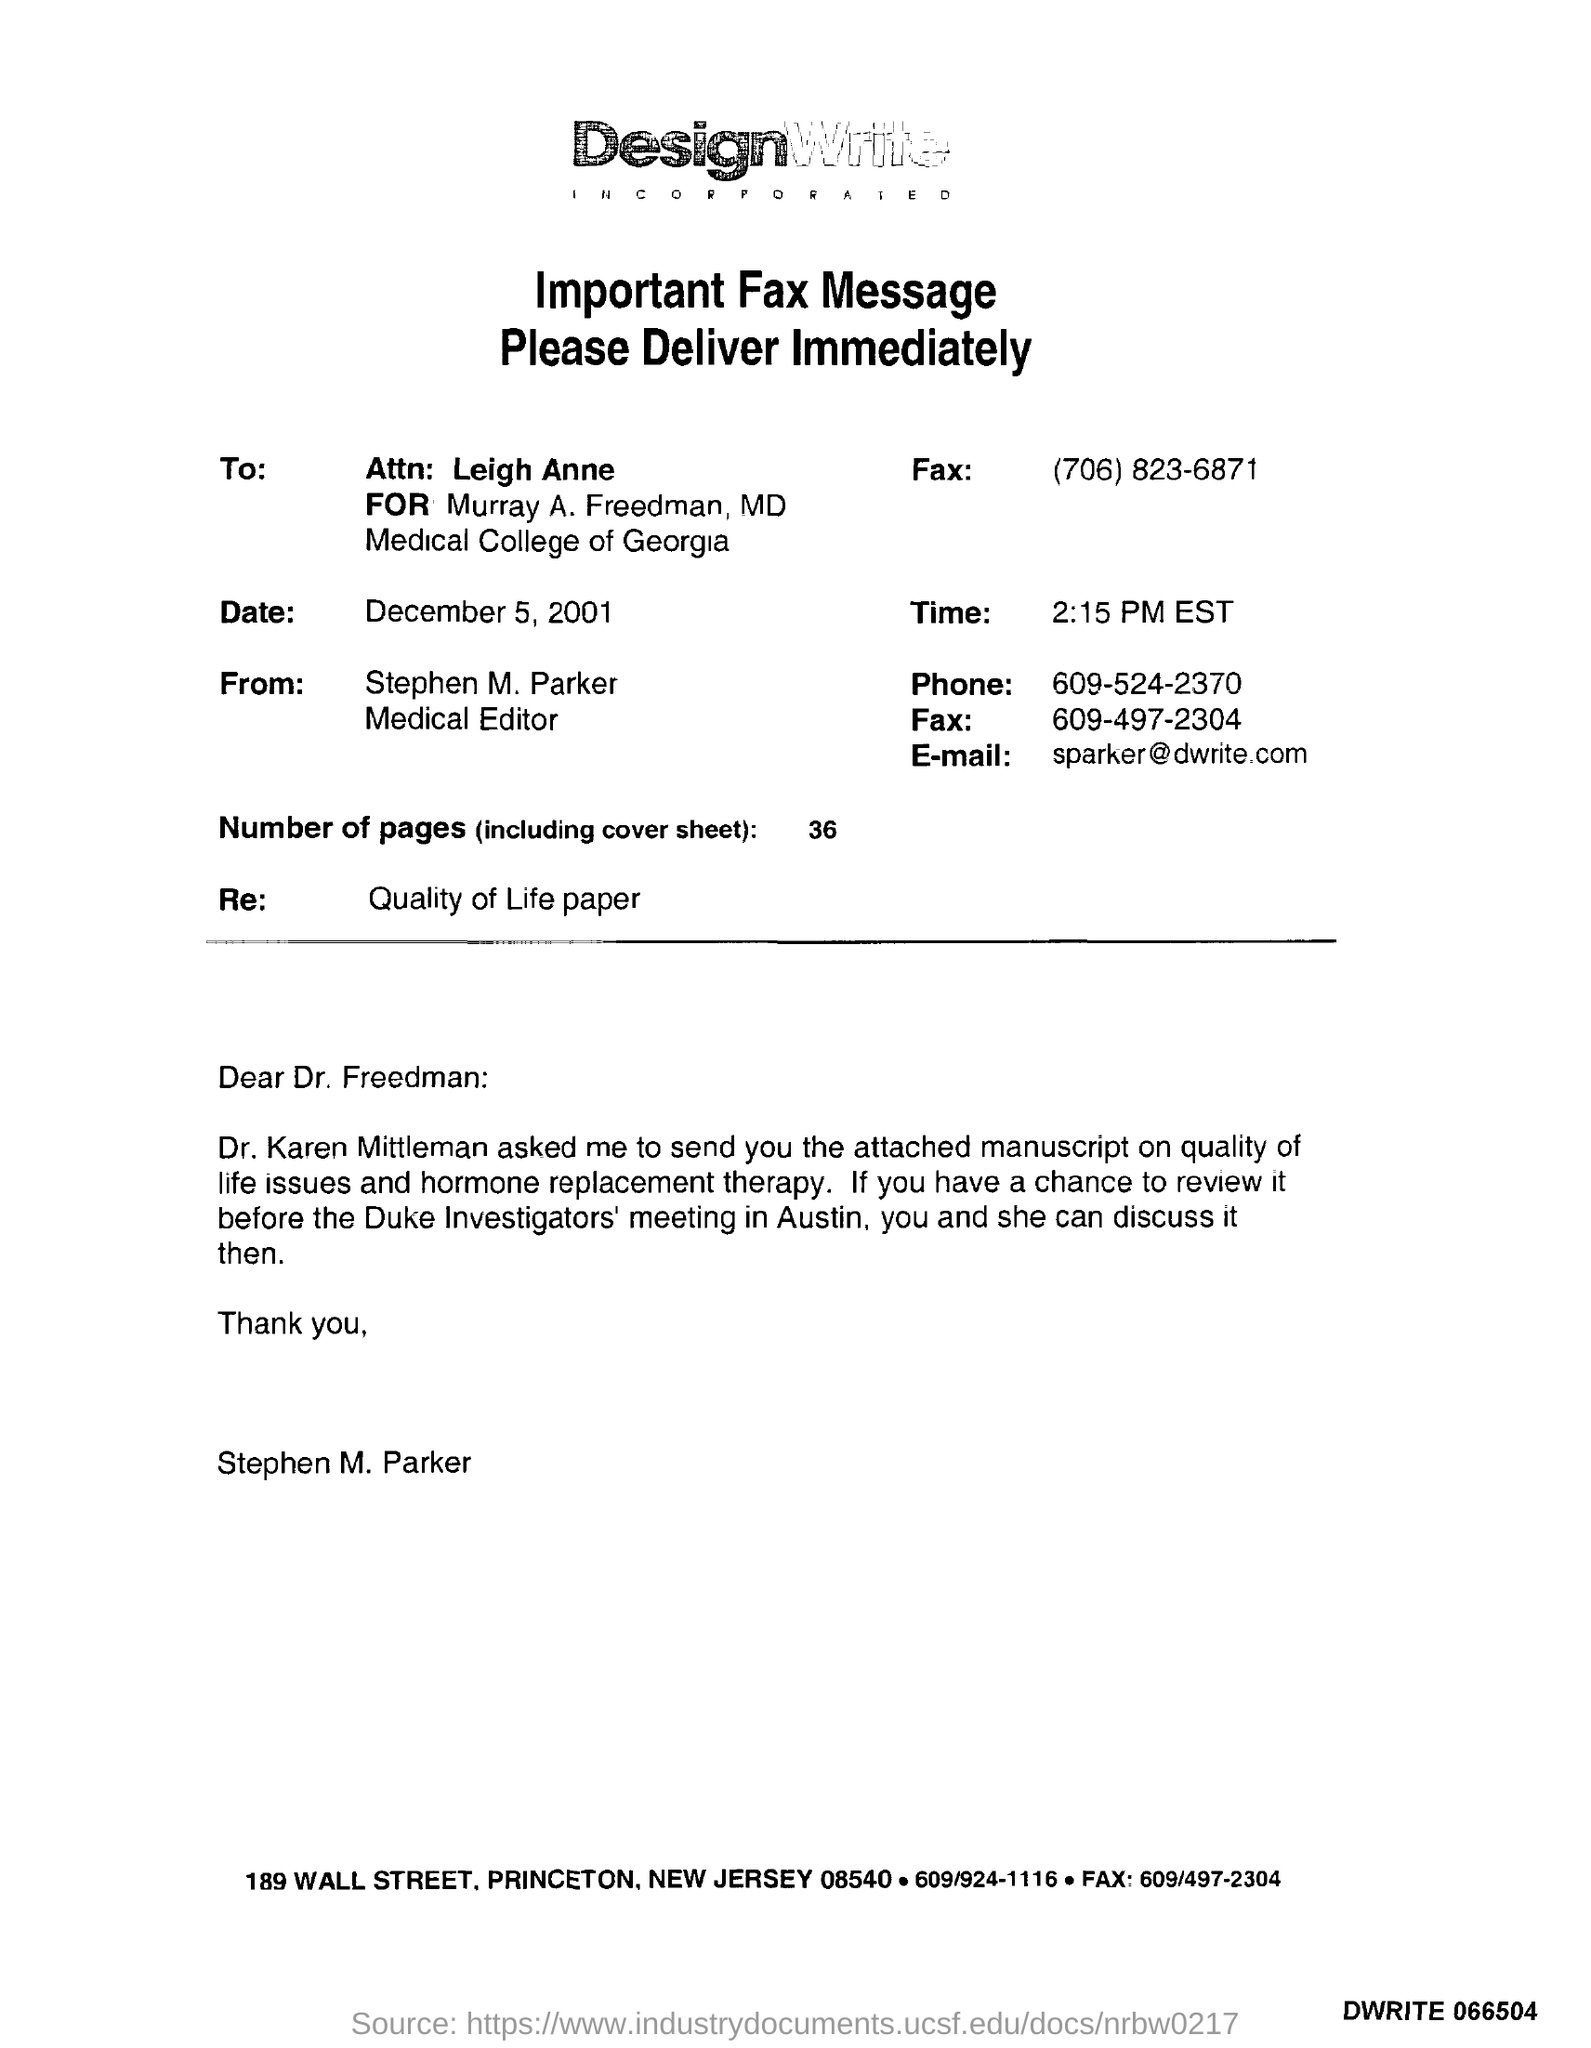Specify some key components in this picture. The date mentioned in the fax is December 5, 2001. The fax belongs to DesignWrite company. The sender of the fax is Stephen M. Parker. Stephen M. Parker holds the designation of Medical Editor. There are 36 pages in the fax, including the cover sheet. 